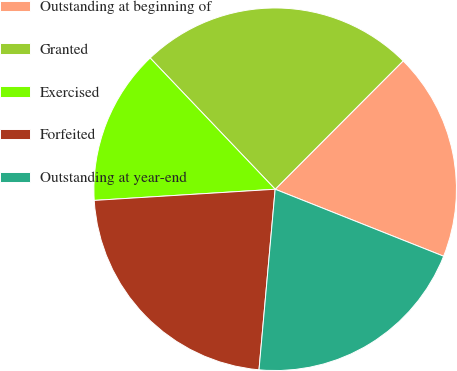<chart> <loc_0><loc_0><loc_500><loc_500><pie_chart><fcel>Outstanding at beginning of<fcel>Granted<fcel>Exercised<fcel>Forfeited<fcel>Outstanding at year-end<nl><fcel>18.55%<fcel>24.59%<fcel>13.87%<fcel>22.6%<fcel>20.4%<nl></chart> 